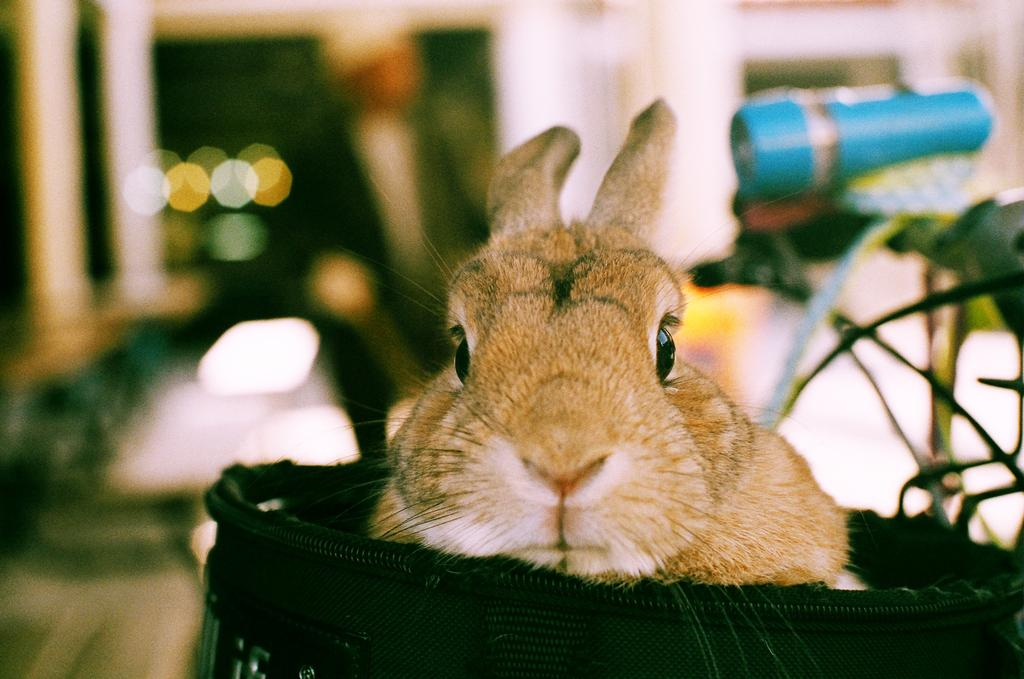What animal can be seen on an object in the image? There is a rabbit on a bag in the image. What furniture is located on the right side of the image? There is a table on the right side of the image. What object is placed on top of the table? There is a torch light on top of the table. How would you describe the background of the image? The background of the image is blurred. What color are the rabbit's eyes in the image? The image does not show the rabbit's eyes, so we cannot determine their color. 